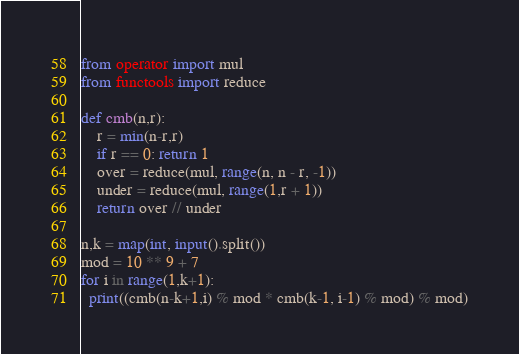<code> <loc_0><loc_0><loc_500><loc_500><_Python_>from operator import mul
from functools import reduce

def cmb(n,r):
    r = min(n-r,r)
    if r == 0: return 1
    over = reduce(mul, range(n, n - r, -1))
    under = reduce(mul, range(1,r + 1))
    return over // under

n,k = map(int, input().split())
mod = 10 ** 9 + 7
for i in range(1,k+1):
  print((cmb(n-k+1,i) % mod * cmb(k-1, i-1) % mod) % mod)
</code> 